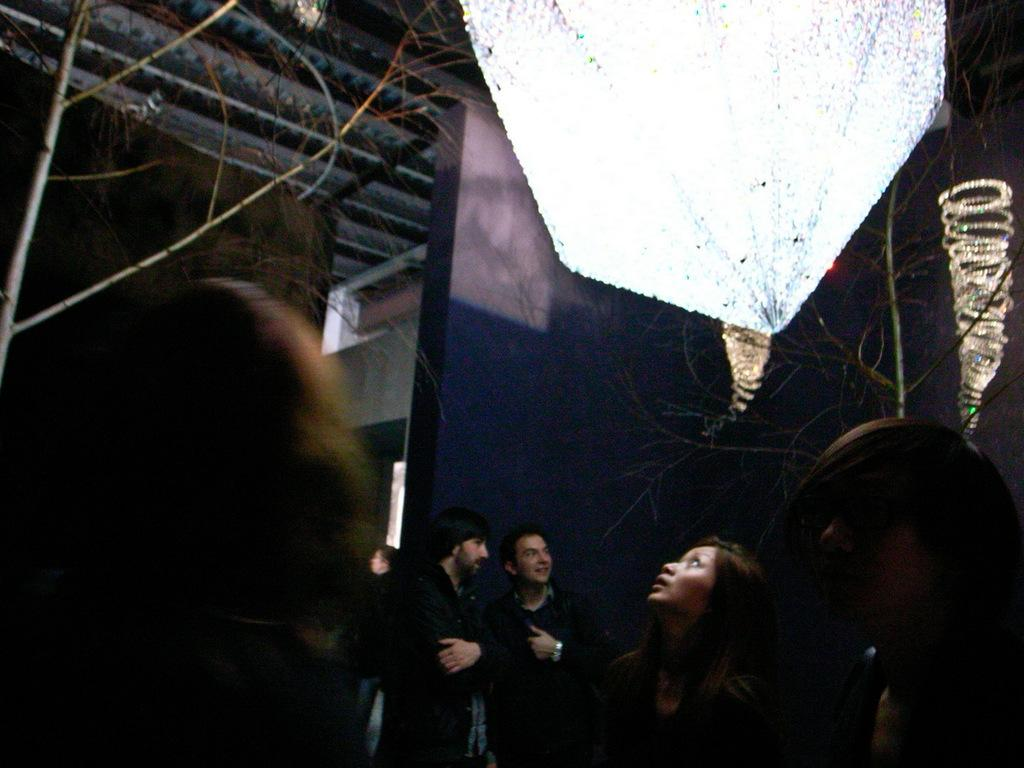What are the people in the image doing? The people in the image are standing and looking up. What can be seen in the background of the image? There is a part of a house and a part of the sky visible in the background of the image. How many cows are on the stage in the image? There are no cows or stage present in the image. 